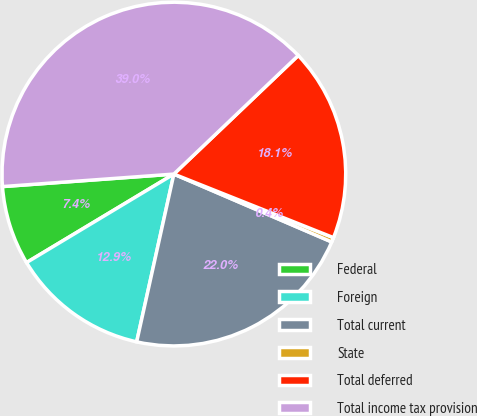Convert chart. <chart><loc_0><loc_0><loc_500><loc_500><pie_chart><fcel>Federal<fcel>Foreign<fcel>Total current<fcel>State<fcel>Total deferred<fcel>Total income tax provision<nl><fcel>7.45%<fcel>12.92%<fcel>22.01%<fcel>0.43%<fcel>18.15%<fcel>39.04%<nl></chart> 